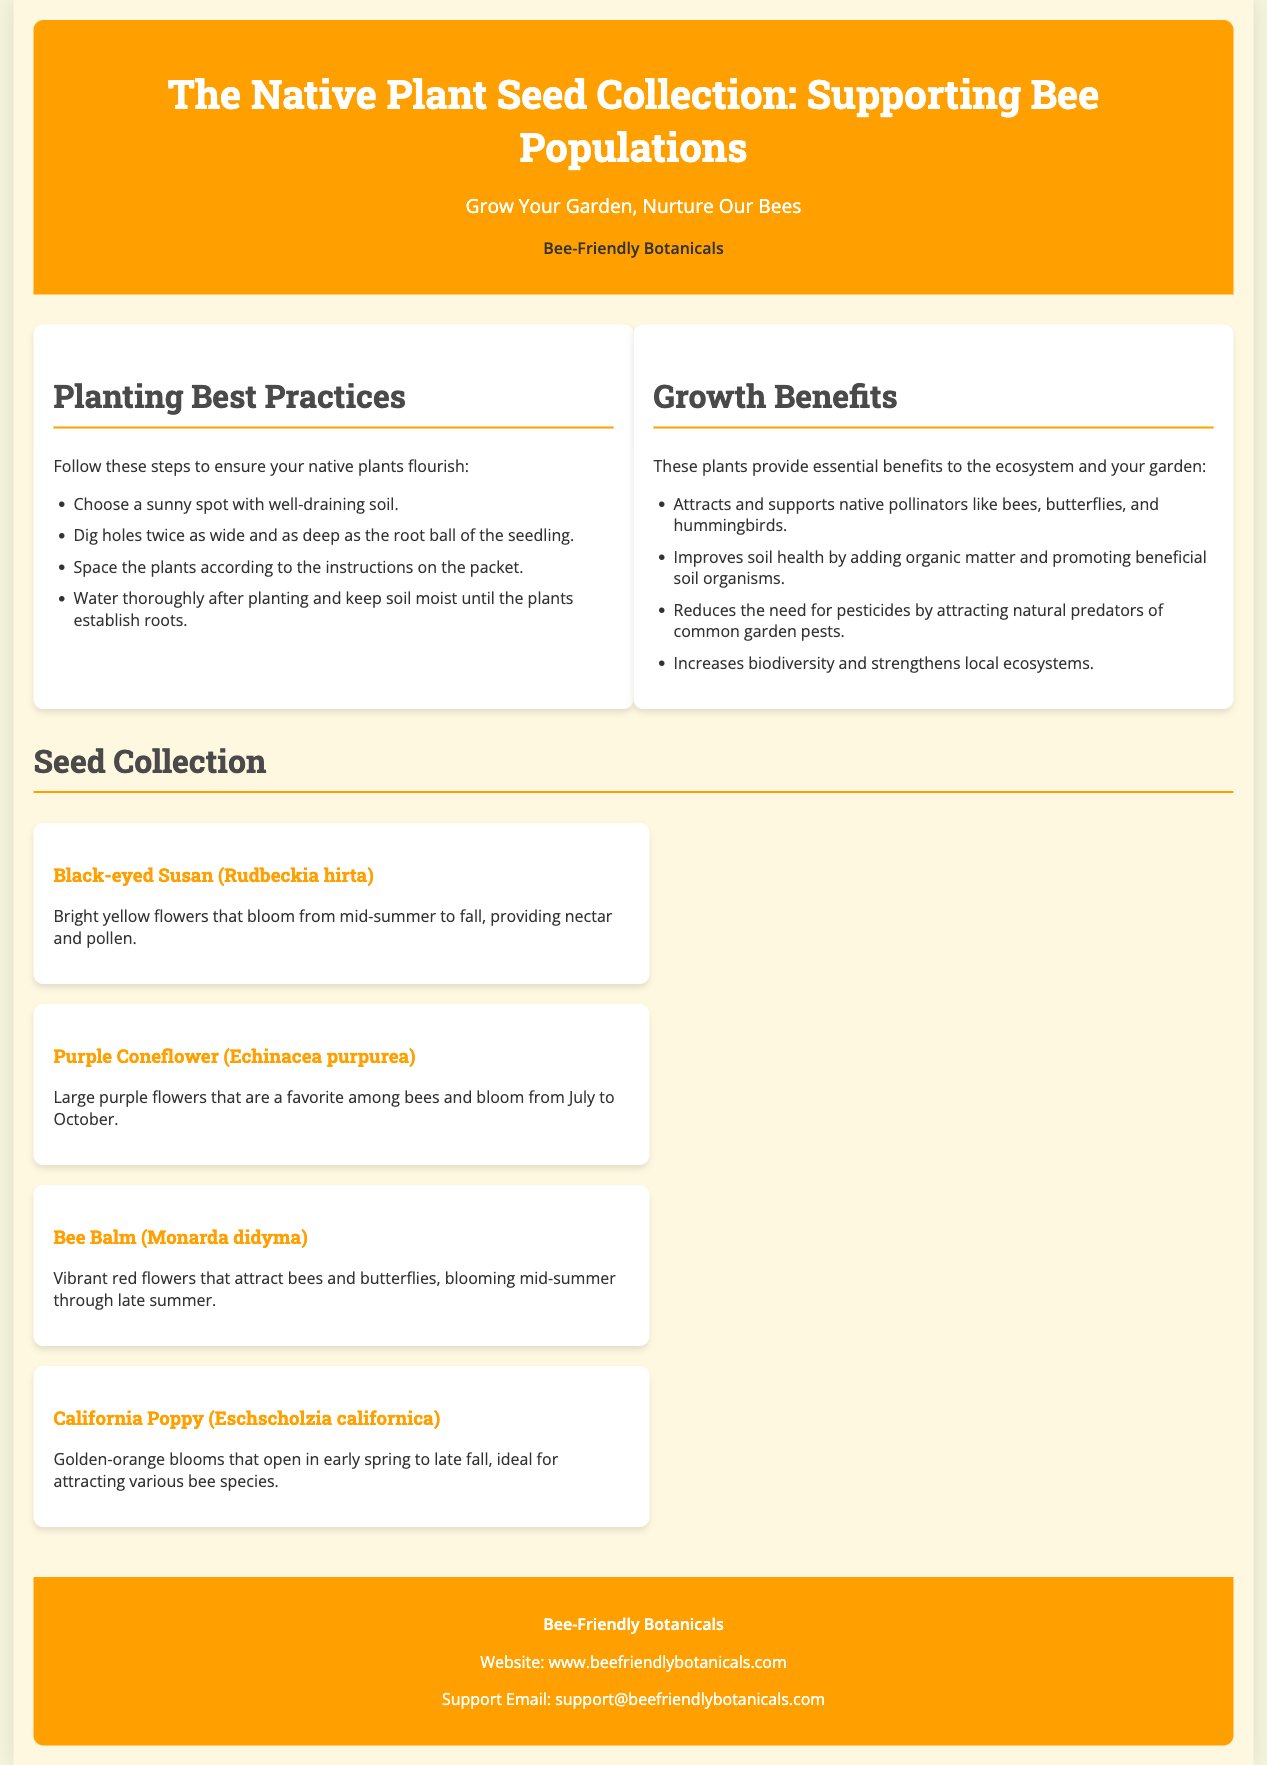What is the name of the collection? The title of the collection is stated at the top of the document, which is 'The Native Plant Seed Collection: Supporting Bee Populations.'
Answer: Native Plant Seed Collection: Supporting Bee Populations What is the subtitle of the collection? The subtitle is provided beneath the main title for branding, which reads 'Grow Your Garden, Nurture Our Bees.'
Answer: Grow Your Garden, Nurture Our Bees How many seed types are listed in the collection? The section titled 'Seed Collection' lists four different types of seeds, each with a description.
Answer: Four What are the colors of the Black-eyed Susan flowers? The document describes the Black-eyed Susan flowers as having bright yellow colors.
Answer: Bright yellow Which plant attracts hummingbirds? The growth benefits section mentions that native plants attract and support native pollinators, including hummingbirds.
Answer: Native plants What is one of the best practices for planting? The visual guide on planting best practices includes steps such as 'Choose a sunny spot with well-draining soil.'
Answer: Choose a sunny spot with well-draining soil What is the main purpose of this seed collection? The main purpose is explicitly stated in the title and the opening paragraph, which is to support bee populations.
Answer: Support bee populations Which flower blooms from mid-summer to fall? The information about the Black-eyed Susan indicates that it blooms from mid-summer to fall.
Answer: Black-eyed Susan What email is provided for support inquiries? The footer section includes a contact email address for support, which is mentioned as 'support@beefriendlybotanicals.com.'
Answer: support@beefriendlybotanicals.com 